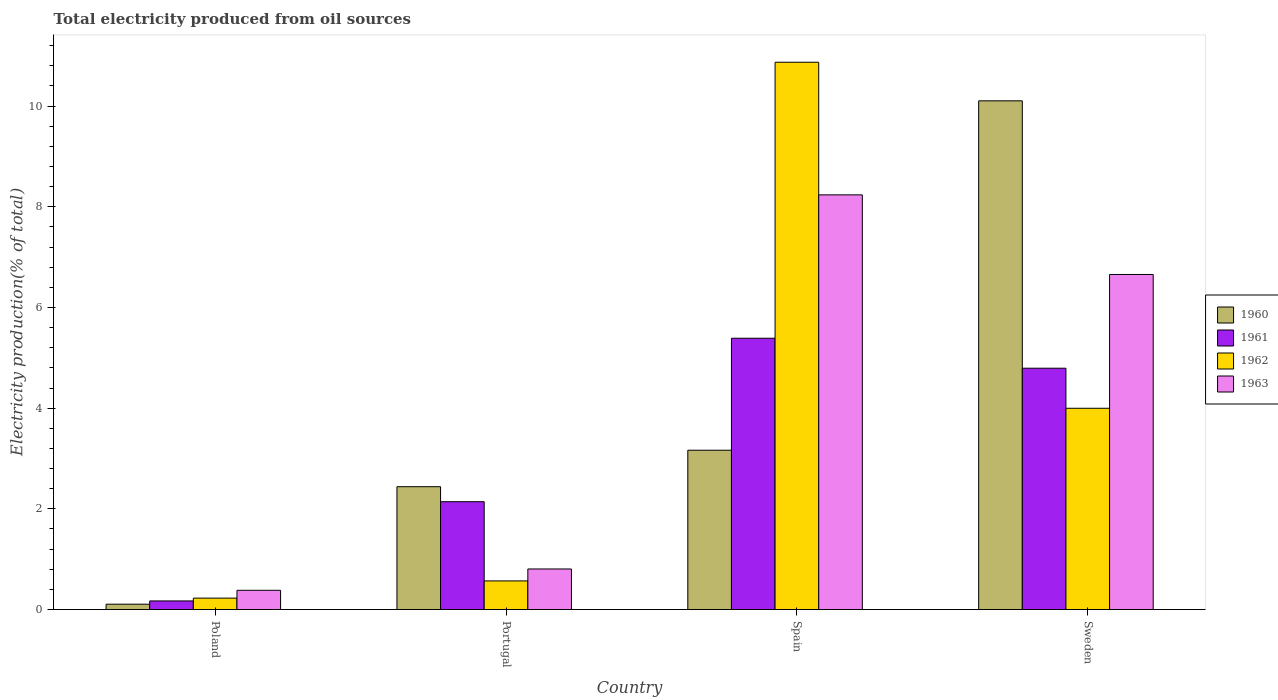How many different coloured bars are there?
Ensure brevity in your answer.  4. How many groups of bars are there?
Give a very brief answer. 4. What is the total electricity produced in 1962 in Spain?
Your response must be concise. 10.87. Across all countries, what is the maximum total electricity produced in 1961?
Provide a succinct answer. 5.39. Across all countries, what is the minimum total electricity produced in 1963?
Provide a succinct answer. 0.38. In which country was the total electricity produced in 1961 minimum?
Your answer should be very brief. Poland. What is the total total electricity produced in 1961 in the graph?
Provide a succinct answer. 12.49. What is the difference between the total electricity produced in 1960 in Spain and that in Sweden?
Your answer should be compact. -6.94. What is the difference between the total electricity produced in 1962 in Portugal and the total electricity produced in 1961 in Spain?
Your answer should be very brief. -4.82. What is the average total electricity produced in 1960 per country?
Offer a terse response. 3.95. What is the difference between the total electricity produced of/in 1960 and total electricity produced of/in 1962 in Spain?
Offer a terse response. -7.71. What is the ratio of the total electricity produced in 1962 in Portugal to that in Spain?
Give a very brief answer. 0.05. Is the total electricity produced in 1963 in Poland less than that in Sweden?
Ensure brevity in your answer.  Yes. Is the difference between the total electricity produced in 1960 in Portugal and Sweden greater than the difference between the total electricity produced in 1962 in Portugal and Sweden?
Provide a short and direct response. No. What is the difference between the highest and the second highest total electricity produced in 1962?
Offer a very short reply. -10.3. What is the difference between the highest and the lowest total electricity produced in 1963?
Provide a succinct answer. 7.85. What does the 2nd bar from the right in Portugal represents?
Provide a short and direct response. 1962. Is it the case that in every country, the sum of the total electricity produced in 1963 and total electricity produced in 1961 is greater than the total electricity produced in 1962?
Your response must be concise. Yes. Are all the bars in the graph horizontal?
Offer a terse response. No. Where does the legend appear in the graph?
Make the answer very short. Center right. How many legend labels are there?
Give a very brief answer. 4. What is the title of the graph?
Your answer should be compact. Total electricity produced from oil sources. Does "2001" appear as one of the legend labels in the graph?
Offer a terse response. No. What is the label or title of the X-axis?
Offer a very short reply. Country. What is the Electricity production(% of total) of 1960 in Poland?
Give a very brief answer. 0.11. What is the Electricity production(% of total) of 1961 in Poland?
Ensure brevity in your answer.  0.17. What is the Electricity production(% of total) of 1962 in Poland?
Ensure brevity in your answer.  0.23. What is the Electricity production(% of total) in 1963 in Poland?
Provide a short and direct response. 0.38. What is the Electricity production(% of total) in 1960 in Portugal?
Your answer should be very brief. 2.44. What is the Electricity production(% of total) of 1961 in Portugal?
Ensure brevity in your answer.  2.14. What is the Electricity production(% of total) in 1962 in Portugal?
Offer a very short reply. 0.57. What is the Electricity production(% of total) in 1963 in Portugal?
Provide a succinct answer. 0.81. What is the Electricity production(% of total) of 1960 in Spain?
Offer a terse response. 3.16. What is the Electricity production(% of total) in 1961 in Spain?
Ensure brevity in your answer.  5.39. What is the Electricity production(% of total) in 1962 in Spain?
Offer a terse response. 10.87. What is the Electricity production(% of total) of 1963 in Spain?
Provide a short and direct response. 8.24. What is the Electricity production(% of total) of 1960 in Sweden?
Provide a short and direct response. 10.1. What is the Electricity production(% of total) in 1961 in Sweden?
Provide a succinct answer. 4.79. What is the Electricity production(% of total) in 1962 in Sweden?
Keep it short and to the point. 4. What is the Electricity production(% of total) of 1963 in Sweden?
Give a very brief answer. 6.66. Across all countries, what is the maximum Electricity production(% of total) of 1960?
Your response must be concise. 10.1. Across all countries, what is the maximum Electricity production(% of total) of 1961?
Ensure brevity in your answer.  5.39. Across all countries, what is the maximum Electricity production(% of total) in 1962?
Your response must be concise. 10.87. Across all countries, what is the maximum Electricity production(% of total) in 1963?
Keep it short and to the point. 8.24. Across all countries, what is the minimum Electricity production(% of total) of 1960?
Offer a very short reply. 0.11. Across all countries, what is the minimum Electricity production(% of total) of 1961?
Offer a terse response. 0.17. Across all countries, what is the minimum Electricity production(% of total) in 1962?
Your answer should be very brief. 0.23. Across all countries, what is the minimum Electricity production(% of total) of 1963?
Your answer should be compact. 0.38. What is the total Electricity production(% of total) in 1960 in the graph?
Provide a short and direct response. 15.81. What is the total Electricity production(% of total) in 1961 in the graph?
Your answer should be very brief. 12.49. What is the total Electricity production(% of total) in 1962 in the graph?
Offer a very short reply. 15.66. What is the total Electricity production(% of total) of 1963 in the graph?
Provide a short and direct response. 16.08. What is the difference between the Electricity production(% of total) in 1960 in Poland and that in Portugal?
Give a very brief answer. -2.33. What is the difference between the Electricity production(% of total) of 1961 in Poland and that in Portugal?
Provide a succinct answer. -1.97. What is the difference between the Electricity production(% of total) of 1962 in Poland and that in Portugal?
Offer a terse response. -0.34. What is the difference between the Electricity production(% of total) in 1963 in Poland and that in Portugal?
Provide a short and direct response. -0.42. What is the difference between the Electricity production(% of total) of 1960 in Poland and that in Spain?
Keep it short and to the point. -3.06. What is the difference between the Electricity production(% of total) of 1961 in Poland and that in Spain?
Give a very brief answer. -5.22. What is the difference between the Electricity production(% of total) of 1962 in Poland and that in Spain?
Your answer should be compact. -10.64. What is the difference between the Electricity production(% of total) of 1963 in Poland and that in Spain?
Give a very brief answer. -7.85. What is the difference between the Electricity production(% of total) in 1960 in Poland and that in Sweden?
Keep it short and to the point. -10. What is the difference between the Electricity production(% of total) in 1961 in Poland and that in Sweden?
Offer a very short reply. -4.62. What is the difference between the Electricity production(% of total) in 1962 in Poland and that in Sweden?
Your answer should be very brief. -3.77. What is the difference between the Electricity production(% of total) of 1963 in Poland and that in Sweden?
Ensure brevity in your answer.  -6.27. What is the difference between the Electricity production(% of total) in 1960 in Portugal and that in Spain?
Give a very brief answer. -0.72. What is the difference between the Electricity production(% of total) in 1961 in Portugal and that in Spain?
Keep it short and to the point. -3.25. What is the difference between the Electricity production(% of total) of 1962 in Portugal and that in Spain?
Your response must be concise. -10.3. What is the difference between the Electricity production(% of total) in 1963 in Portugal and that in Spain?
Your response must be concise. -7.43. What is the difference between the Electricity production(% of total) in 1960 in Portugal and that in Sweden?
Keep it short and to the point. -7.66. What is the difference between the Electricity production(% of total) in 1961 in Portugal and that in Sweden?
Offer a terse response. -2.65. What is the difference between the Electricity production(% of total) in 1962 in Portugal and that in Sweden?
Give a very brief answer. -3.43. What is the difference between the Electricity production(% of total) in 1963 in Portugal and that in Sweden?
Keep it short and to the point. -5.85. What is the difference between the Electricity production(% of total) in 1960 in Spain and that in Sweden?
Offer a very short reply. -6.94. What is the difference between the Electricity production(% of total) in 1961 in Spain and that in Sweden?
Your response must be concise. 0.6. What is the difference between the Electricity production(% of total) of 1962 in Spain and that in Sweden?
Provide a short and direct response. 6.87. What is the difference between the Electricity production(% of total) in 1963 in Spain and that in Sweden?
Provide a succinct answer. 1.58. What is the difference between the Electricity production(% of total) of 1960 in Poland and the Electricity production(% of total) of 1961 in Portugal?
Offer a very short reply. -2.04. What is the difference between the Electricity production(% of total) of 1960 in Poland and the Electricity production(% of total) of 1962 in Portugal?
Your response must be concise. -0.46. What is the difference between the Electricity production(% of total) of 1960 in Poland and the Electricity production(% of total) of 1963 in Portugal?
Your answer should be compact. -0.7. What is the difference between the Electricity production(% of total) in 1961 in Poland and the Electricity production(% of total) in 1962 in Portugal?
Your answer should be compact. -0.4. What is the difference between the Electricity production(% of total) of 1961 in Poland and the Electricity production(% of total) of 1963 in Portugal?
Offer a very short reply. -0.63. What is the difference between the Electricity production(% of total) in 1962 in Poland and the Electricity production(% of total) in 1963 in Portugal?
Provide a short and direct response. -0.58. What is the difference between the Electricity production(% of total) in 1960 in Poland and the Electricity production(% of total) in 1961 in Spain?
Your response must be concise. -5.28. What is the difference between the Electricity production(% of total) of 1960 in Poland and the Electricity production(% of total) of 1962 in Spain?
Keep it short and to the point. -10.77. What is the difference between the Electricity production(% of total) in 1960 in Poland and the Electricity production(% of total) in 1963 in Spain?
Offer a terse response. -8.13. What is the difference between the Electricity production(% of total) in 1961 in Poland and the Electricity production(% of total) in 1962 in Spain?
Ensure brevity in your answer.  -10.7. What is the difference between the Electricity production(% of total) in 1961 in Poland and the Electricity production(% of total) in 1963 in Spain?
Give a very brief answer. -8.07. What is the difference between the Electricity production(% of total) of 1962 in Poland and the Electricity production(% of total) of 1963 in Spain?
Provide a short and direct response. -8.01. What is the difference between the Electricity production(% of total) in 1960 in Poland and the Electricity production(% of total) in 1961 in Sweden?
Your answer should be compact. -4.69. What is the difference between the Electricity production(% of total) in 1960 in Poland and the Electricity production(% of total) in 1962 in Sweden?
Your answer should be very brief. -3.89. What is the difference between the Electricity production(% of total) of 1960 in Poland and the Electricity production(% of total) of 1963 in Sweden?
Your response must be concise. -6.55. What is the difference between the Electricity production(% of total) in 1961 in Poland and the Electricity production(% of total) in 1962 in Sweden?
Make the answer very short. -3.83. What is the difference between the Electricity production(% of total) in 1961 in Poland and the Electricity production(% of total) in 1963 in Sweden?
Ensure brevity in your answer.  -6.48. What is the difference between the Electricity production(% of total) in 1962 in Poland and the Electricity production(% of total) in 1963 in Sweden?
Provide a succinct answer. -6.43. What is the difference between the Electricity production(% of total) of 1960 in Portugal and the Electricity production(% of total) of 1961 in Spain?
Your answer should be very brief. -2.95. What is the difference between the Electricity production(% of total) of 1960 in Portugal and the Electricity production(% of total) of 1962 in Spain?
Provide a short and direct response. -8.43. What is the difference between the Electricity production(% of total) of 1960 in Portugal and the Electricity production(% of total) of 1963 in Spain?
Offer a very short reply. -5.8. What is the difference between the Electricity production(% of total) in 1961 in Portugal and the Electricity production(% of total) in 1962 in Spain?
Ensure brevity in your answer.  -8.73. What is the difference between the Electricity production(% of total) of 1961 in Portugal and the Electricity production(% of total) of 1963 in Spain?
Provide a succinct answer. -6.09. What is the difference between the Electricity production(% of total) of 1962 in Portugal and the Electricity production(% of total) of 1963 in Spain?
Provide a short and direct response. -7.67. What is the difference between the Electricity production(% of total) in 1960 in Portugal and the Electricity production(% of total) in 1961 in Sweden?
Make the answer very short. -2.35. What is the difference between the Electricity production(% of total) in 1960 in Portugal and the Electricity production(% of total) in 1962 in Sweden?
Your response must be concise. -1.56. What is the difference between the Electricity production(% of total) in 1960 in Portugal and the Electricity production(% of total) in 1963 in Sweden?
Provide a succinct answer. -4.22. What is the difference between the Electricity production(% of total) of 1961 in Portugal and the Electricity production(% of total) of 1962 in Sweden?
Provide a short and direct response. -1.86. What is the difference between the Electricity production(% of total) in 1961 in Portugal and the Electricity production(% of total) in 1963 in Sweden?
Ensure brevity in your answer.  -4.51. What is the difference between the Electricity production(% of total) in 1962 in Portugal and the Electricity production(% of total) in 1963 in Sweden?
Your answer should be compact. -6.09. What is the difference between the Electricity production(% of total) in 1960 in Spain and the Electricity production(% of total) in 1961 in Sweden?
Your answer should be compact. -1.63. What is the difference between the Electricity production(% of total) of 1960 in Spain and the Electricity production(% of total) of 1962 in Sweden?
Your answer should be very brief. -0.83. What is the difference between the Electricity production(% of total) in 1960 in Spain and the Electricity production(% of total) in 1963 in Sweden?
Offer a terse response. -3.49. What is the difference between the Electricity production(% of total) of 1961 in Spain and the Electricity production(% of total) of 1962 in Sweden?
Offer a very short reply. 1.39. What is the difference between the Electricity production(% of total) of 1961 in Spain and the Electricity production(% of total) of 1963 in Sweden?
Your answer should be very brief. -1.27. What is the difference between the Electricity production(% of total) in 1962 in Spain and the Electricity production(% of total) in 1963 in Sweden?
Ensure brevity in your answer.  4.22. What is the average Electricity production(% of total) of 1960 per country?
Ensure brevity in your answer.  3.95. What is the average Electricity production(% of total) of 1961 per country?
Keep it short and to the point. 3.12. What is the average Electricity production(% of total) in 1962 per country?
Provide a succinct answer. 3.92. What is the average Electricity production(% of total) of 1963 per country?
Keep it short and to the point. 4.02. What is the difference between the Electricity production(% of total) of 1960 and Electricity production(% of total) of 1961 in Poland?
Provide a short and direct response. -0.06. What is the difference between the Electricity production(% of total) in 1960 and Electricity production(% of total) in 1962 in Poland?
Your answer should be very brief. -0.12. What is the difference between the Electricity production(% of total) of 1960 and Electricity production(% of total) of 1963 in Poland?
Ensure brevity in your answer.  -0.28. What is the difference between the Electricity production(% of total) in 1961 and Electricity production(% of total) in 1962 in Poland?
Your answer should be very brief. -0.06. What is the difference between the Electricity production(% of total) in 1961 and Electricity production(% of total) in 1963 in Poland?
Your answer should be compact. -0.21. What is the difference between the Electricity production(% of total) in 1962 and Electricity production(% of total) in 1963 in Poland?
Provide a short and direct response. -0.16. What is the difference between the Electricity production(% of total) of 1960 and Electricity production(% of total) of 1961 in Portugal?
Your answer should be compact. 0.3. What is the difference between the Electricity production(% of total) in 1960 and Electricity production(% of total) in 1962 in Portugal?
Give a very brief answer. 1.87. What is the difference between the Electricity production(% of total) in 1960 and Electricity production(% of total) in 1963 in Portugal?
Make the answer very short. 1.63. What is the difference between the Electricity production(% of total) in 1961 and Electricity production(% of total) in 1962 in Portugal?
Provide a succinct answer. 1.57. What is the difference between the Electricity production(% of total) of 1961 and Electricity production(% of total) of 1963 in Portugal?
Give a very brief answer. 1.34. What is the difference between the Electricity production(% of total) of 1962 and Electricity production(% of total) of 1963 in Portugal?
Give a very brief answer. -0.24. What is the difference between the Electricity production(% of total) in 1960 and Electricity production(% of total) in 1961 in Spain?
Your answer should be very brief. -2.22. What is the difference between the Electricity production(% of total) in 1960 and Electricity production(% of total) in 1962 in Spain?
Ensure brevity in your answer.  -7.71. What is the difference between the Electricity production(% of total) of 1960 and Electricity production(% of total) of 1963 in Spain?
Keep it short and to the point. -5.07. What is the difference between the Electricity production(% of total) in 1961 and Electricity production(% of total) in 1962 in Spain?
Your answer should be very brief. -5.48. What is the difference between the Electricity production(% of total) of 1961 and Electricity production(% of total) of 1963 in Spain?
Make the answer very short. -2.85. What is the difference between the Electricity production(% of total) in 1962 and Electricity production(% of total) in 1963 in Spain?
Provide a succinct answer. 2.63. What is the difference between the Electricity production(% of total) of 1960 and Electricity production(% of total) of 1961 in Sweden?
Make the answer very short. 5.31. What is the difference between the Electricity production(% of total) in 1960 and Electricity production(% of total) in 1962 in Sweden?
Provide a short and direct response. 6.11. What is the difference between the Electricity production(% of total) of 1960 and Electricity production(% of total) of 1963 in Sweden?
Provide a short and direct response. 3.45. What is the difference between the Electricity production(% of total) of 1961 and Electricity production(% of total) of 1962 in Sweden?
Your answer should be compact. 0.8. What is the difference between the Electricity production(% of total) of 1961 and Electricity production(% of total) of 1963 in Sweden?
Your response must be concise. -1.86. What is the difference between the Electricity production(% of total) in 1962 and Electricity production(% of total) in 1963 in Sweden?
Ensure brevity in your answer.  -2.66. What is the ratio of the Electricity production(% of total) in 1960 in Poland to that in Portugal?
Offer a very short reply. 0.04. What is the ratio of the Electricity production(% of total) in 1961 in Poland to that in Portugal?
Give a very brief answer. 0.08. What is the ratio of the Electricity production(% of total) of 1962 in Poland to that in Portugal?
Provide a succinct answer. 0.4. What is the ratio of the Electricity production(% of total) of 1963 in Poland to that in Portugal?
Ensure brevity in your answer.  0.47. What is the ratio of the Electricity production(% of total) in 1960 in Poland to that in Spain?
Provide a succinct answer. 0.03. What is the ratio of the Electricity production(% of total) of 1961 in Poland to that in Spain?
Keep it short and to the point. 0.03. What is the ratio of the Electricity production(% of total) of 1962 in Poland to that in Spain?
Your response must be concise. 0.02. What is the ratio of the Electricity production(% of total) of 1963 in Poland to that in Spain?
Offer a very short reply. 0.05. What is the ratio of the Electricity production(% of total) in 1960 in Poland to that in Sweden?
Your response must be concise. 0.01. What is the ratio of the Electricity production(% of total) in 1961 in Poland to that in Sweden?
Offer a very short reply. 0.04. What is the ratio of the Electricity production(% of total) of 1962 in Poland to that in Sweden?
Offer a terse response. 0.06. What is the ratio of the Electricity production(% of total) of 1963 in Poland to that in Sweden?
Your answer should be compact. 0.06. What is the ratio of the Electricity production(% of total) in 1960 in Portugal to that in Spain?
Provide a succinct answer. 0.77. What is the ratio of the Electricity production(% of total) in 1961 in Portugal to that in Spain?
Ensure brevity in your answer.  0.4. What is the ratio of the Electricity production(% of total) in 1962 in Portugal to that in Spain?
Keep it short and to the point. 0.05. What is the ratio of the Electricity production(% of total) in 1963 in Portugal to that in Spain?
Your answer should be compact. 0.1. What is the ratio of the Electricity production(% of total) in 1960 in Portugal to that in Sweden?
Keep it short and to the point. 0.24. What is the ratio of the Electricity production(% of total) of 1961 in Portugal to that in Sweden?
Your answer should be compact. 0.45. What is the ratio of the Electricity production(% of total) of 1962 in Portugal to that in Sweden?
Your answer should be very brief. 0.14. What is the ratio of the Electricity production(% of total) in 1963 in Portugal to that in Sweden?
Ensure brevity in your answer.  0.12. What is the ratio of the Electricity production(% of total) of 1960 in Spain to that in Sweden?
Provide a succinct answer. 0.31. What is the ratio of the Electricity production(% of total) in 1961 in Spain to that in Sweden?
Make the answer very short. 1.12. What is the ratio of the Electricity production(% of total) in 1962 in Spain to that in Sweden?
Make the answer very short. 2.72. What is the ratio of the Electricity production(% of total) of 1963 in Spain to that in Sweden?
Your response must be concise. 1.24. What is the difference between the highest and the second highest Electricity production(% of total) of 1960?
Your response must be concise. 6.94. What is the difference between the highest and the second highest Electricity production(% of total) of 1961?
Offer a terse response. 0.6. What is the difference between the highest and the second highest Electricity production(% of total) of 1962?
Give a very brief answer. 6.87. What is the difference between the highest and the second highest Electricity production(% of total) in 1963?
Give a very brief answer. 1.58. What is the difference between the highest and the lowest Electricity production(% of total) in 1960?
Ensure brevity in your answer.  10. What is the difference between the highest and the lowest Electricity production(% of total) of 1961?
Keep it short and to the point. 5.22. What is the difference between the highest and the lowest Electricity production(% of total) in 1962?
Offer a very short reply. 10.64. What is the difference between the highest and the lowest Electricity production(% of total) in 1963?
Your answer should be very brief. 7.85. 